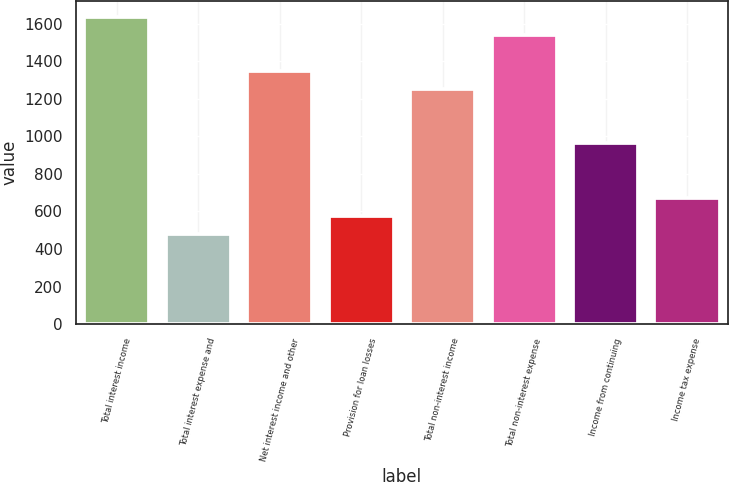<chart> <loc_0><loc_0><loc_500><loc_500><bar_chart><fcel>Total interest income<fcel>Total interest expense and<fcel>Net interest income and other<fcel>Provision for loan losses<fcel>Total non-interest income<fcel>Total non-interest expense<fcel>Income from continuing<fcel>Income tax expense<nl><fcel>1636.99<fcel>481.51<fcel>1348.12<fcel>577.8<fcel>1251.83<fcel>1540.7<fcel>962.96<fcel>674.09<nl></chart> 